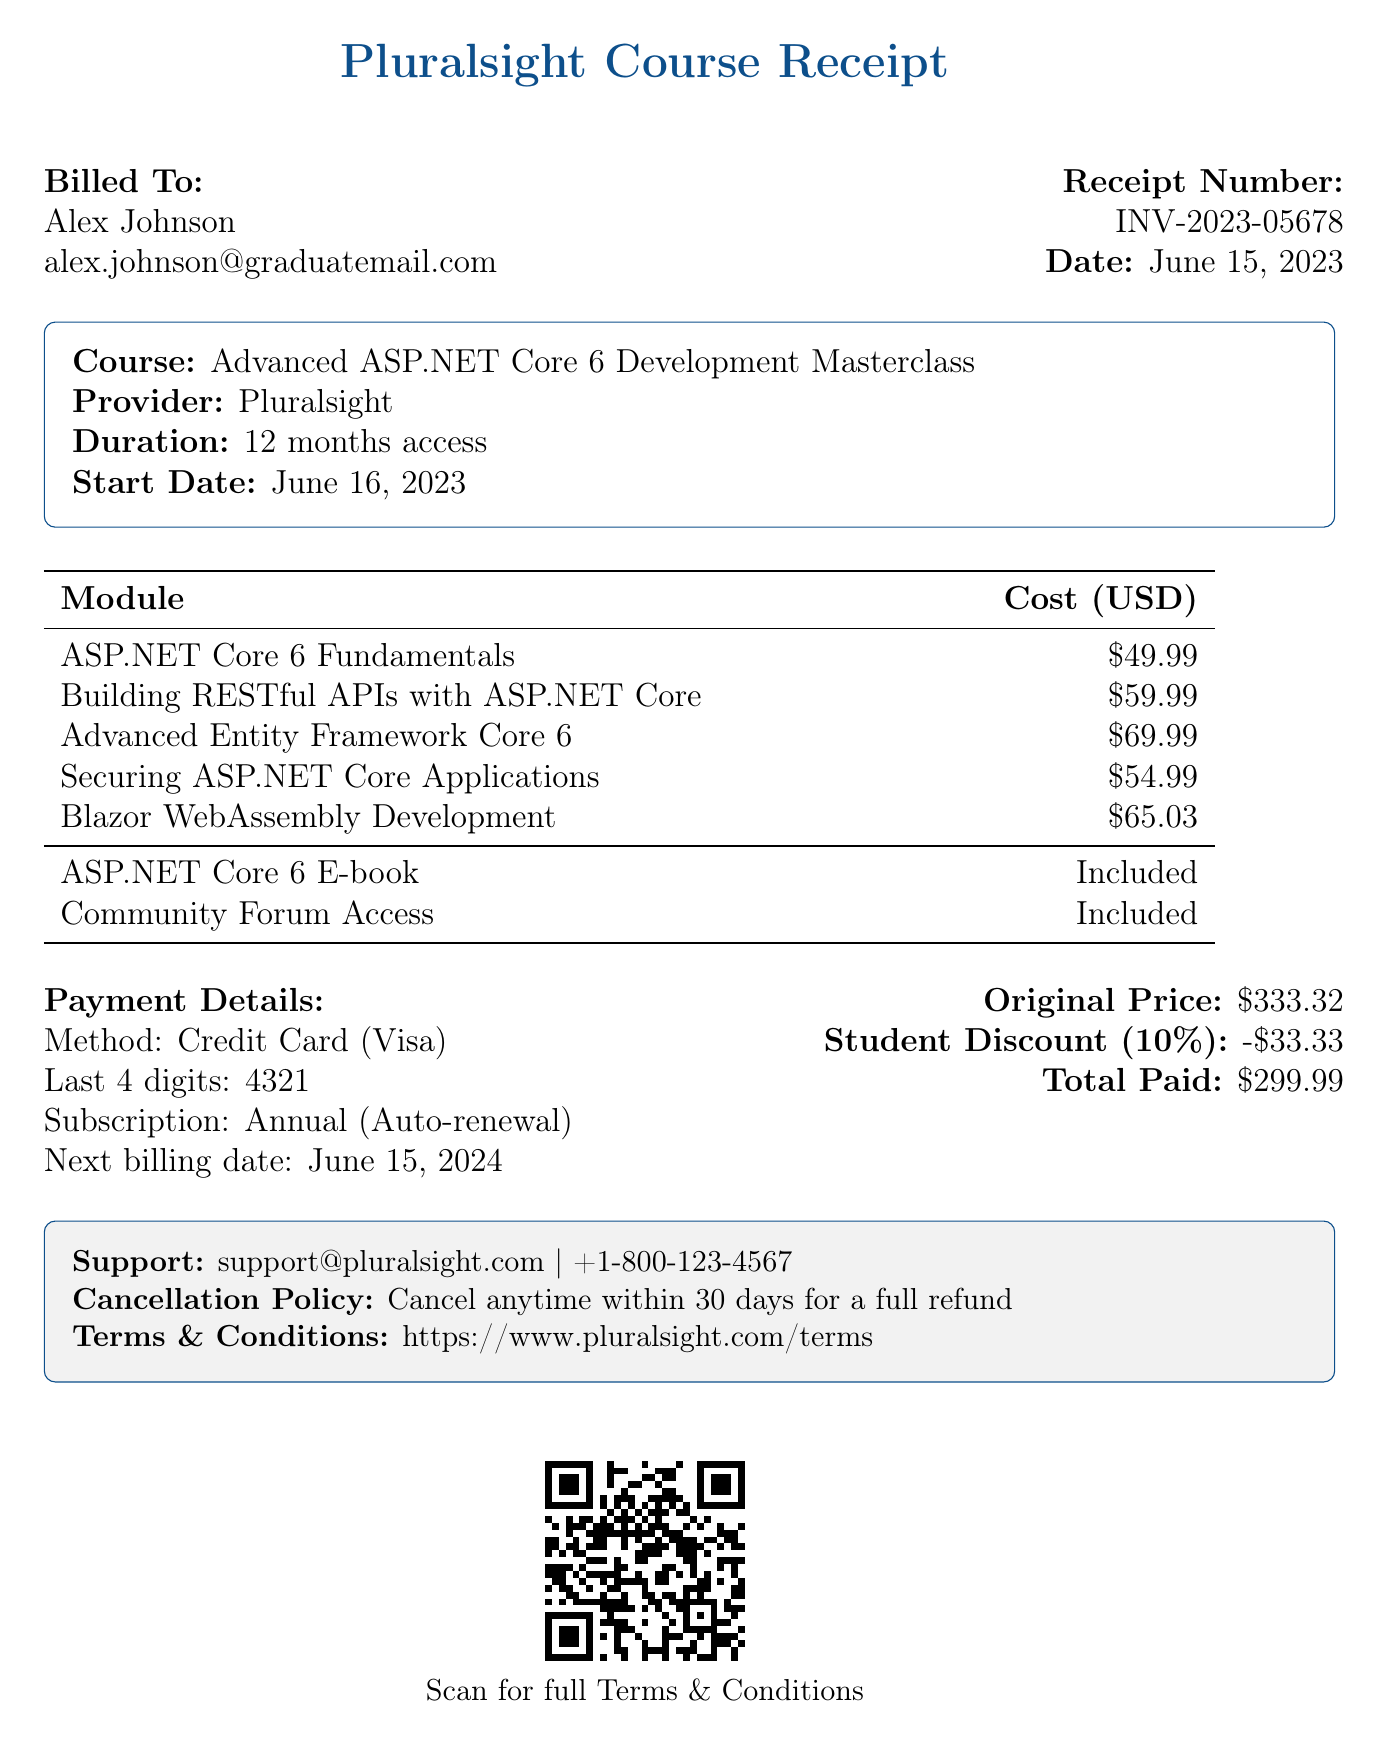What is the receipt number? The receipt number is a unique identifier for the transaction provided in the document, which is INV-2023-05678.
Answer: INV-2023-05678 What is the course title? The course title, which represents the main focus of the subscription, is mentioned in the document as Advanced ASP.NET Core 6 Development Masterclass.
Answer: Advanced ASP.NET Core 6 Development Masterclass How many modules are included in the course? The document lists five modules, reflecting the various topics covered in the course.
Answer: 5 What is the total cost of the course? The total cost is computed based on the modules and any applicable discounts, which results in an amount stated as 299.99.
Answer: 299.99 What type of payment method was used? The payment method used for the transaction is specified to be a Credit Card.
Answer: Credit Card What is the duration of access to the course? The document clearly states the duration of access, which is 12 months.
Answer: 12 months When is the next billing date? The next billing date is the specific date mentioned for future payments, which is June 15, 2024.
Answer: June 15, 2024 Was a student discount applied? The document indicates that a student discount was indeed applied to the total course cost.
Answer: Yes What is the cancellation policy? The cancellation policy provides guidance on how users can cancel their subscription and is described in the document as allowing cancellations for a full refund within 30 days.
Answer: Cancel anytime within 30 days for a full refund 